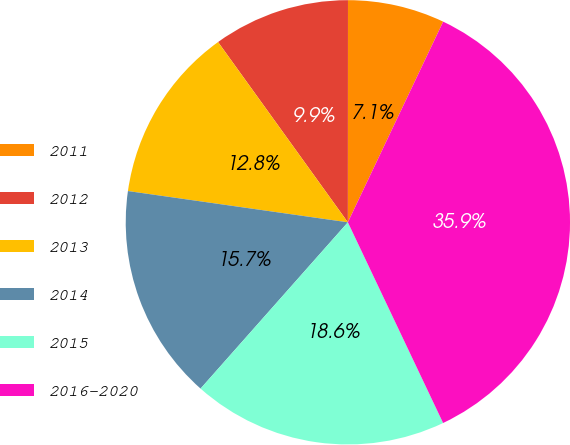<chart> <loc_0><loc_0><loc_500><loc_500><pie_chart><fcel>2011<fcel>2012<fcel>2013<fcel>2014<fcel>2015<fcel>2016-2020<nl><fcel>7.05%<fcel>9.94%<fcel>12.82%<fcel>15.71%<fcel>18.59%<fcel>35.89%<nl></chart> 